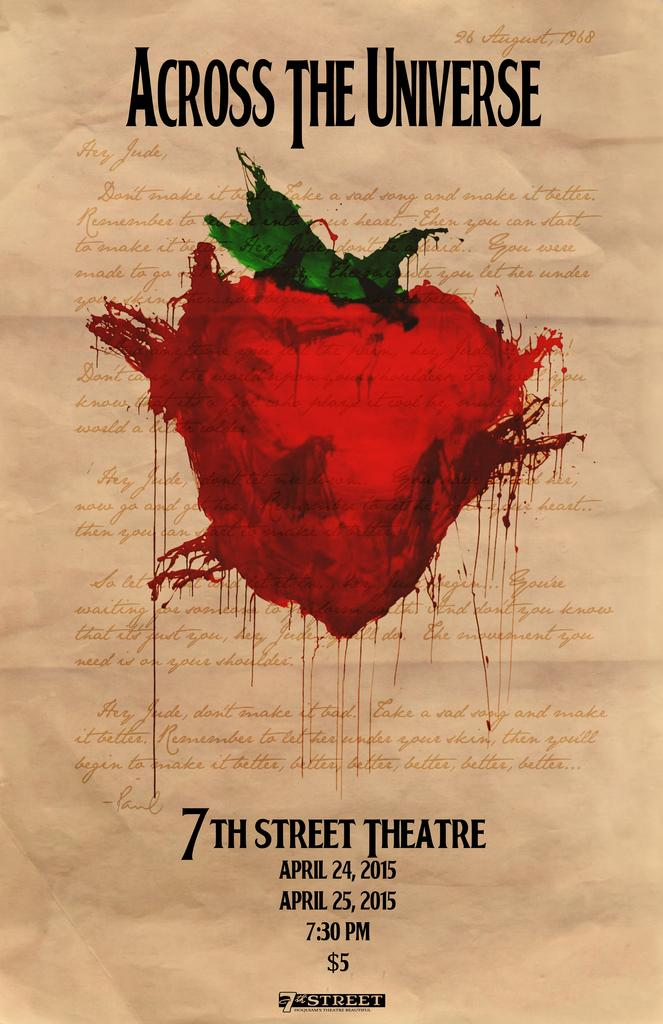<image>
Summarize the visual content of the image. A theater advertisement called across the universe has red heart shaped with a green leaves on top. 